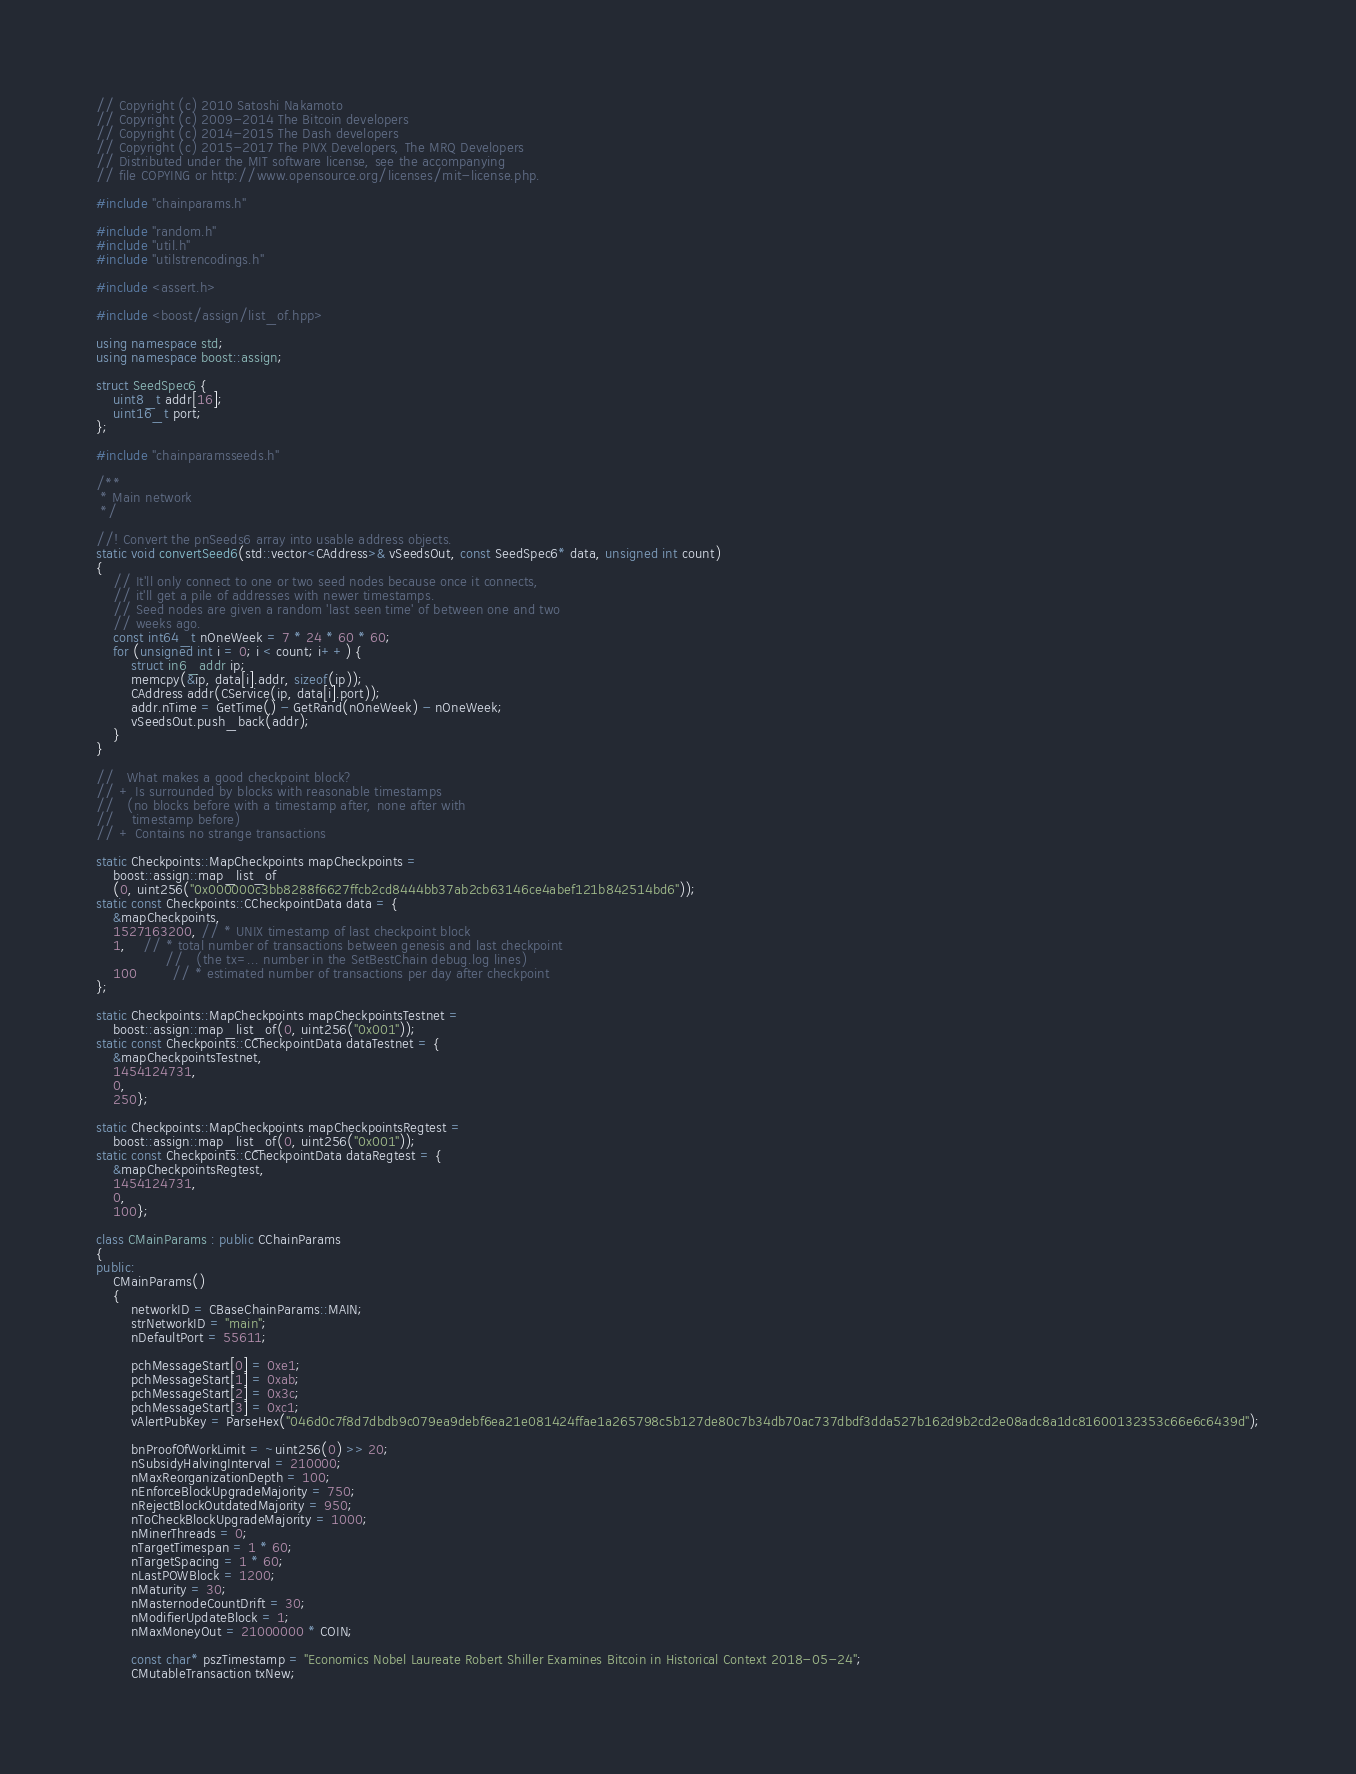Convert code to text. <code><loc_0><loc_0><loc_500><loc_500><_C++_>// Copyright (c) 2010 Satoshi Nakamoto
// Copyright (c) 2009-2014 The Bitcoin developers
// Copyright (c) 2014-2015 The Dash developers
// Copyright (c) 2015-2017 The PIVX Developers, The MRQ Developers
// Distributed under the MIT software license, see the accompanying
// file COPYING or http://www.opensource.org/licenses/mit-license.php.

#include "chainparams.h"

#include "random.h"
#include "util.h"
#include "utilstrencodings.h"

#include <assert.h>

#include <boost/assign/list_of.hpp>

using namespace std;
using namespace boost::assign;

struct SeedSpec6 {
    uint8_t addr[16];
    uint16_t port;
};

#include "chainparamsseeds.h"

/**
 * Main network
 */

//! Convert the pnSeeds6 array into usable address objects.
static void convertSeed6(std::vector<CAddress>& vSeedsOut, const SeedSpec6* data, unsigned int count)
{
    // It'll only connect to one or two seed nodes because once it connects,
    // it'll get a pile of addresses with newer timestamps.
    // Seed nodes are given a random 'last seen time' of between one and two
    // weeks ago.
    const int64_t nOneWeek = 7 * 24 * 60 * 60;
    for (unsigned int i = 0; i < count; i++) {
        struct in6_addr ip;
        memcpy(&ip, data[i].addr, sizeof(ip));
        CAddress addr(CService(ip, data[i].port));
        addr.nTime = GetTime() - GetRand(nOneWeek) - nOneWeek;
        vSeedsOut.push_back(addr);
    }
}

//   What makes a good checkpoint block?
// + Is surrounded by blocks with reasonable timestamps
//   (no blocks before with a timestamp after, none after with
//    timestamp before)
// + Contains no strange transactions

static Checkpoints::MapCheckpoints mapCheckpoints =
    boost::assign::map_list_of
    (0, uint256("0x000000c3bb8288f6627ffcb2cd8444bb37ab2cb63146ce4abef121b842514bd6"));
static const Checkpoints::CCheckpointData data = {
    &mapCheckpoints,
    1527163200, // * UNIX timestamp of last checkpoint block
    1,    // * total number of transactions between genesis and last checkpoint
                //   (the tx=... number in the SetBestChain debug.log lines)
    100        // * estimated number of transactions per day after checkpoint
};

static Checkpoints::MapCheckpoints mapCheckpointsTestnet =
    boost::assign::map_list_of(0, uint256("0x001"));
static const Checkpoints::CCheckpointData dataTestnet = {
    &mapCheckpointsTestnet,
    1454124731,
    0,
    250};

static Checkpoints::MapCheckpoints mapCheckpointsRegtest =
    boost::assign::map_list_of(0, uint256("0x001"));
static const Checkpoints::CCheckpointData dataRegtest = {
    &mapCheckpointsRegtest,
    1454124731,
    0,
    100};

class CMainParams : public CChainParams
{
public:
    CMainParams()
    {
        networkID = CBaseChainParams::MAIN;
        strNetworkID = "main";
        nDefaultPort = 55611;

        pchMessageStart[0] = 0xe1;
        pchMessageStart[1] = 0xab;
        pchMessageStart[2] = 0x3c;
        pchMessageStart[3] = 0xc1;
        vAlertPubKey = ParseHex("046d0c7f8d7dbdb9c079ea9debf6ea21e081424ffae1a265798c5b127de80c7b34db70ac737dbdf3dda527b162d9b2cd2e08adc8a1dc81600132353c66e6c6439d");
        
        bnProofOfWorkLimit = ~uint256(0) >> 20;
        nSubsidyHalvingInterval = 210000;
        nMaxReorganizationDepth = 100;
        nEnforceBlockUpgradeMajority = 750;
        nRejectBlockOutdatedMajority = 950;
        nToCheckBlockUpgradeMajority = 1000;
        nMinerThreads = 0;
        nTargetTimespan = 1 * 60;
        nTargetSpacing = 1 * 60;
        nLastPOWBlock = 1200;
        nMaturity = 30;
        nMasternodeCountDrift = 30;
        nModifierUpdateBlock = 1;
        nMaxMoneyOut = 21000000 * COIN;

        const char* pszTimestamp = "Economics Nobel Laureate Robert Shiller Examines Bitcoin in Historical Context 2018-05-24";
        CMutableTransaction txNew;</code> 